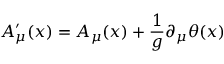<formula> <loc_0><loc_0><loc_500><loc_500>A _ { \mu } ^ { \prime } ( x ) = A _ { \mu } ( x ) + { \frac { 1 } { g } } \partial _ { \mu } \theta ( x )</formula> 